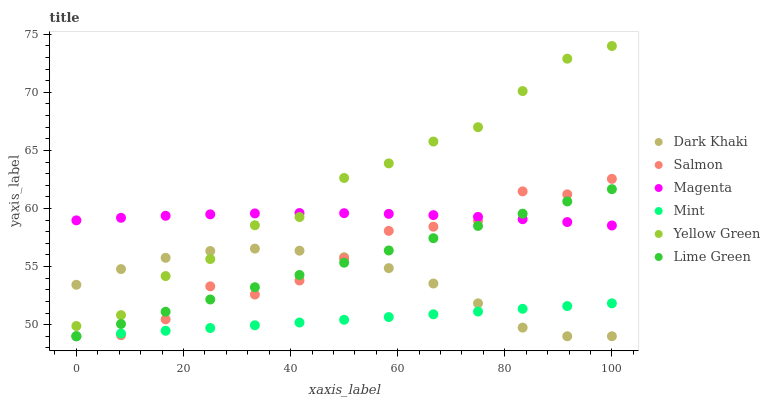Does Mint have the minimum area under the curve?
Answer yes or no. Yes. Does Yellow Green have the maximum area under the curve?
Answer yes or no. Yes. Does Lime Green have the minimum area under the curve?
Answer yes or no. No. Does Lime Green have the maximum area under the curve?
Answer yes or no. No. Is Mint the smoothest?
Answer yes or no. Yes. Is Salmon the roughest?
Answer yes or no. Yes. Is Lime Green the smoothest?
Answer yes or no. No. Is Lime Green the roughest?
Answer yes or no. No. Does Lime Green have the lowest value?
Answer yes or no. Yes. Does Magenta have the lowest value?
Answer yes or no. No. Does Yellow Green have the highest value?
Answer yes or no. Yes. Does Lime Green have the highest value?
Answer yes or no. No. Is Dark Khaki less than Magenta?
Answer yes or no. Yes. Is Magenta greater than Mint?
Answer yes or no. Yes. Does Mint intersect Salmon?
Answer yes or no. Yes. Is Mint less than Salmon?
Answer yes or no. No. Is Mint greater than Salmon?
Answer yes or no. No. Does Dark Khaki intersect Magenta?
Answer yes or no. No. 